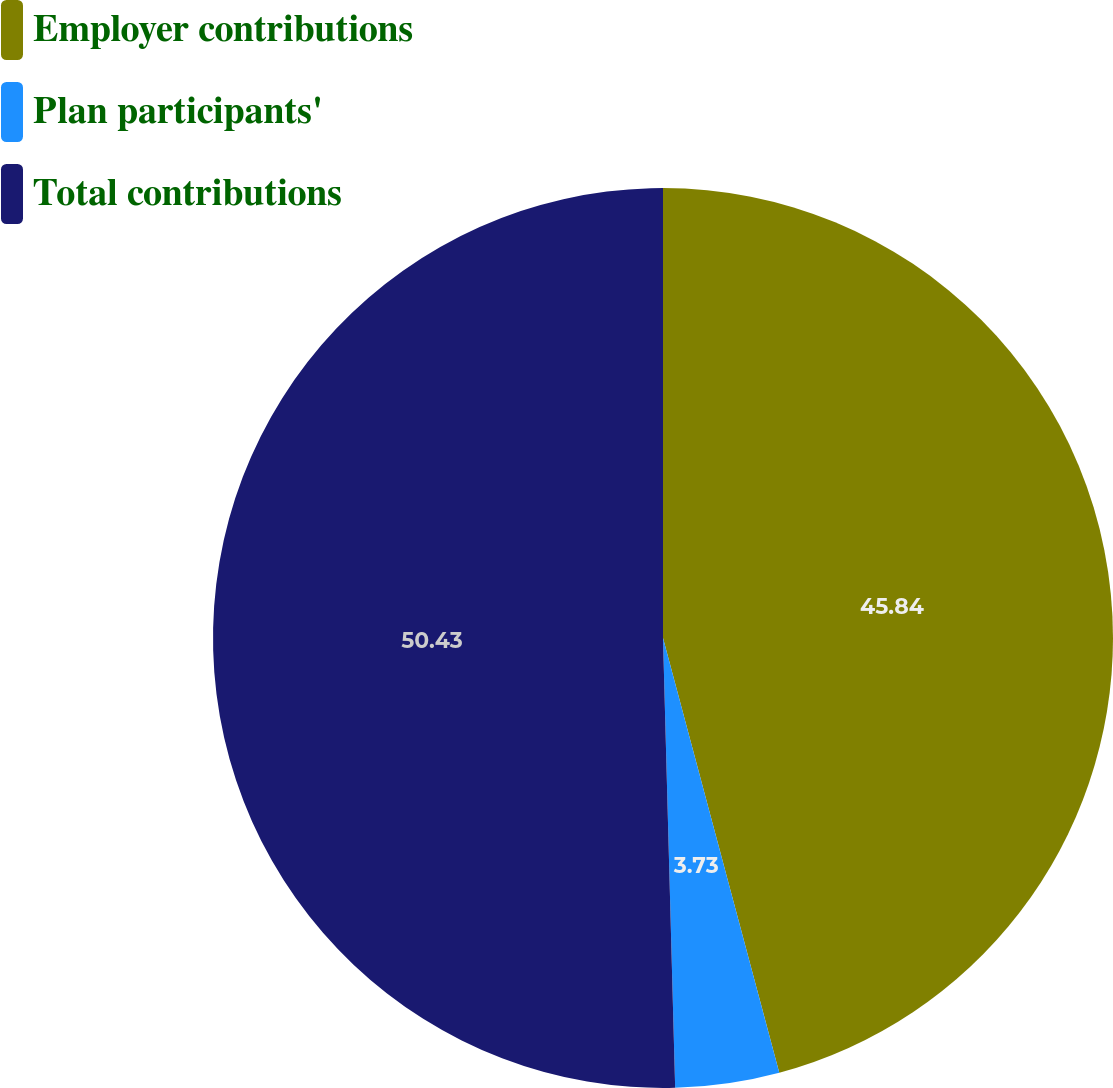Convert chart to OTSL. <chart><loc_0><loc_0><loc_500><loc_500><pie_chart><fcel>Employer contributions<fcel>Plan participants'<fcel>Total contributions<nl><fcel>45.84%<fcel>3.73%<fcel>50.43%<nl></chart> 